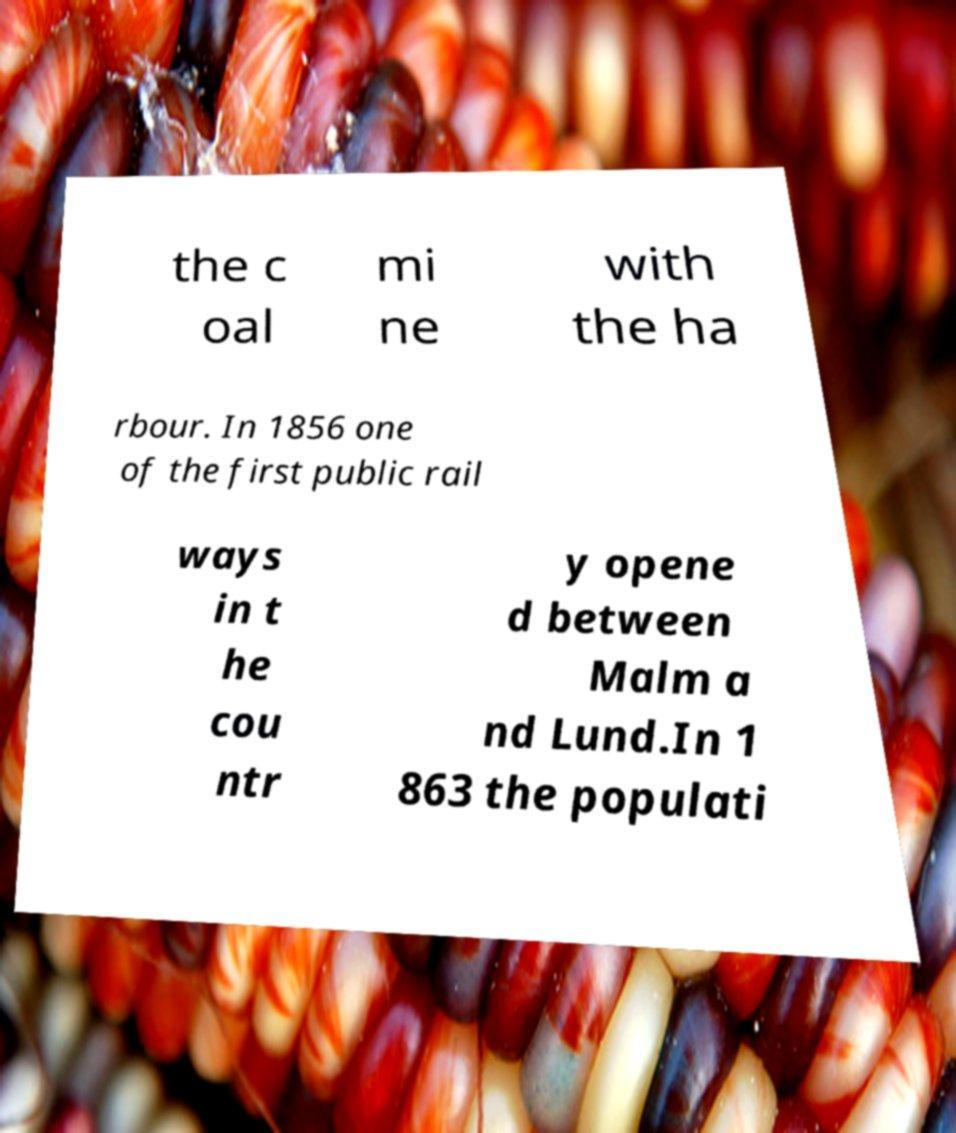For documentation purposes, I need the text within this image transcribed. Could you provide that? the c oal mi ne with the ha rbour. In 1856 one of the first public rail ways in t he cou ntr y opene d between Malm a nd Lund.In 1 863 the populati 